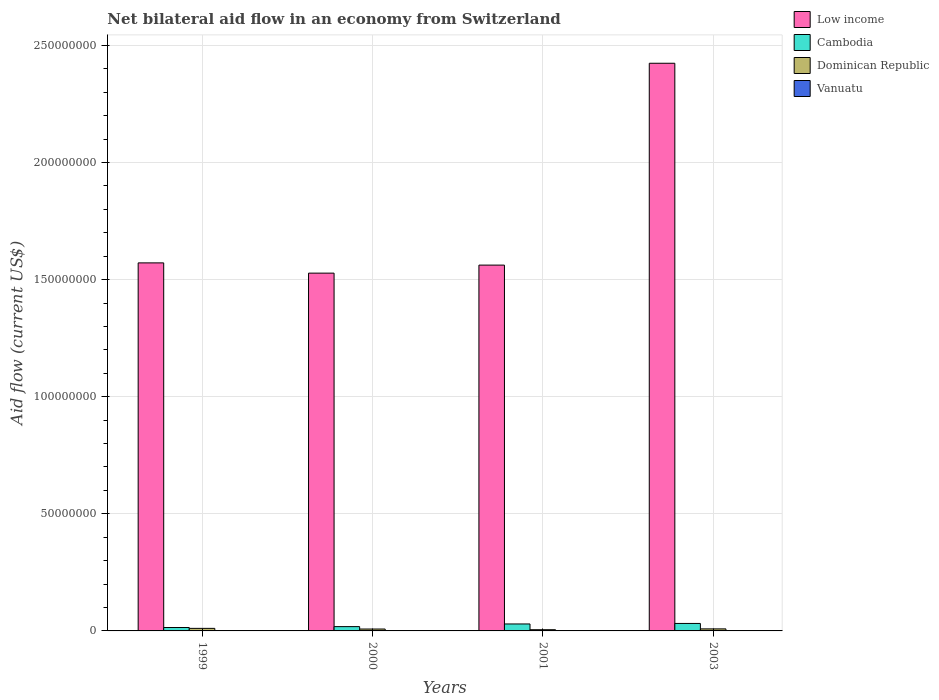How many groups of bars are there?
Offer a terse response. 4. Are the number of bars on each tick of the X-axis equal?
Make the answer very short. Yes. How many bars are there on the 4th tick from the left?
Offer a terse response. 4. In how many cases, is the number of bars for a given year not equal to the number of legend labels?
Offer a terse response. 0. What is the net bilateral aid flow in Low income in 2003?
Make the answer very short. 2.42e+08. Across all years, what is the maximum net bilateral aid flow in Dominican Republic?
Give a very brief answer. 1.09e+06. Across all years, what is the minimum net bilateral aid flow in Dominican Republic?
Provide a short and direct response. 5.20e+05. In which year was the net bilateral aid flow in Dominican Republic maximum?
Your response must be concise. 1999. In which year was the net bilateral aid flow in Dominican Republic minimum?
Provide a succinct answer. 2001. What is the difference between the net bilateral aid flow in Low income in 1999 and that in 2003?
Your answer should be very brief. -8.52e+07. What is the difference between the net bilateral aid flow in Low income in 2000 and the net bilateral aid flow in Cambodia in 2003?
Make the answer very short. 1.50e+08. What is the average net bilateral aid flow in Low income per year?
Provide a short and direct response. 1.77e+08. In the year 2000, what is the difference between the net bilateral aid flow in Low income and net bilateral aid flow in Cambodia?
Provide a succinct answer. 1.51e+08. In how many years, is the net bilateral aid flow in Low income greater than 180000000 US$?
Offer a very short reply. 1. What is the ratio of the net bilateral aid flow in Low income in 2000 to that in 2003?
Give a very brief answer. 0.63. Is the net bilateral aid flow in Low income in 2000 less than that in 2003?
Offer a terse response. Yes. Is the difference between the net bilateral aid flow in Low income in 2001 and 2003 greater than the difference between the net bilateral aid flow in Cambodia in 2001 and 2003?
Provide a succinct answer. No. What is the difference between the highest and the second highest net bilateral aid flow in Cambodia?
Provide a succinct answer. 2.20e+05. What is the difference between the highest and the lowest net bilateral aid flow in Dominican Republic?
Your answer should be very brief. 5.70e+05. In how many years, is the net bilateral aid flow in Cambodia greater than the average net bilateral aid flow in Cambodia taken over all years?
Your response must be concise. 2. What does the 4th bar from the left in 2001 represents?
Offer a terse response. Vanuatu. What does the 3rd bar from the right in 2001 represents?
Keep it short and to the point. Cambodia. Are the values on the major ticks of Y-axis written in scientific E-notation?
Provide a succinct answer. No. How many legend labels are there?
Offer a very short reply. 4. What is the title of the graph?
Your answer should be compact. Net bilateral aid flow in an economy from Switzerland. Does "Ukraine" appear as one of the legend labels in the graph?
Offer a very short reply. No. What is the label or title of the Y-axis?
Provide a short and direct response. Aid flow (current US$). What is the Aid flow (current US$) in Low income in 1999?
Offer a terse response. 1.57e+08. What is the Aid flow (current US$) of Cambodia in 1999?
Make the answer very short. 1.46e+06. What is the Aid flow (current US$) of Dominican Republic in 1999?
Ensure brevity in your answer.  1.09e+06. What is the Aid flow (current US$) of Low income in 2000?
Your response must be concise. 1.53e+08. What is the Aid flow (current US$) of Cambodia in 2000?
Keep it short and to the point. 1.84e+06. What is the Aid flow (current US$) in Dominican Republic in 2000?
Ensure brevity in your answer.  8.10e+05. What is the Aid flow (current US$) in Vanuatu in 2000?
Offer a very short reply. 2.00e+04. What is the Aid flow (current US$) in Low income in 2001?
Give a very brief answer. 1.56e+08. What is the Aid flow (current US$) of Cambodia in 2001?
Provide a succinct answer. 2.97e+06. What is the Aid flow (current US$) of Dominican Republic in 2001?
Your response must be concise. 5.20e+05. What is the Aid flow (current US$) of Low income in 2003?
Ensure brevity in your answer.  2.42e+08. What is the Aid flow (current US$) in Cambodia in 2003?
Ensure brevity in your answer.  3.19e+06. What is the Aid flow (current US$) of Dominican Republic in 2003?
Your response must be concise. 8.70e+05. What is the Aid flow (current US$) of Vanuatu in 2003?
Your answer should be compact. 10000. Across all years, what is the maximum Aid flow (current US$) in Low income?
Provide a succinct answer. 2.42e+08. Across all years, what is the maximum Aid flow (current US$) in Cambodia?
Give a very brief answer. 3.19e+06. Across all years, what is the maximum Aid flow (current US$) in Dominican Republic?
Offer a terse response. 1.09e+06. Across all years, what is the maximum Aid flow (current US$) in Vanuatu?
Offer a terse response. 2.00e+04. Across all years, what is the minimum Aid flow (current US$) in Low income?
Offer a very short reply. 1.53e+08. Across all years, what is the minimum Aid flow (current US$) of Cambodia?
Provide a short and direct response. 1.46e+06. Across all years, what is the minimum Aid flow (current US$) in Dominican Republic?
Offer a very short reply. 5.20e+05. Across all years, what is the minimum Aid flow (current US$) in Vanuatu?
Your response must be concise. 10000. What is the total Aid flow (current US$) of Low income in the graph?
Make the answer very short. 7.09e+08. What is the total Aid flow (current US$) of Cambodia in the graph?
Your answer should be very brief. 9.46e+06. What is the total Aid flow (current US$) in Dominican Republic in the graph?
Keep it short and to the point. 3.29e+06. What is the total Aid flow (current US$) in Vanuatu in the graph?
Offer a very short reply. 7.00e+04. What is the difference between the Aid flow (current US$) of Low income in 1999 and that in 2000?
Keep it short and to the point. 4.38e+06. What is the difference between the Aid flow (current US$) in Cambodia in 1999 and that in 2000?
Keep it short and to the point. -3.80e+05. What is the difference between the Aid flow (current US$) of Low income in 1999 and that in 2001?
Make the answer very short. 9.50e+05. What is the difference between the Aid flow (current US$) of Cambodia in 1999 and that in 2001?
Offer a very short reply. -1.51e+06. What is the difference between the Aid flow (current US$) in Dominican Republic in 1999 and that in 2001?
Make the answer very short. 5.70e+05. What is the difference between the Aid flow (current US$) in Low income in 1999 and that in 2003?
Give a very brief answer. -8.52e+07. What is the difference between the Aid flow (current US$) in Cambodia in 1999 and that in 2003?
Give a very brief answer. -1.73e+06. What is the difference between the Aid flow (current US$) in Dominican Republic in 1999 and that in 2003?
Your response must be concise. 2.20e+05. What is the difference between the Aid flow (current US$) of Low income in 2000 and that in 2001?
Give a very brief answer. -3.43e+06. What is the difference between the Aid flow (current US$) in Cambodia in 2000 and that in 2001?
Your answer should be compact. -1.13e+06. What is the difference between the Aid flow (current US$) in Dominican Republic in 2000 and that in 2001?
Make the answer very short. 2.90e+05. What is the difference between the Aid flow (current US$) in Vanuatu in 2000 and that in 2001?
Make the answer very short. 0. What is the difference between the Aid flow (current US$) in Low income in 2000 and that in 2003?
Your answer should be compact. -8.96e+07. What is the difference between the Aid flow (current US$) in Cambodia in 2000 and that in 2003?
Give a very brief answer. -1.35e+06. What is the difference between the Aid flow (current US$) of Dominican Republic in 2000 and that in 2003?
Your answer should be compact. -6.00e+04. What is the difference between the Aid flow (current US$) of Low income in 2001 and that in 2003?
Your response must be concise. -8.62e+07. What is the difference between the Aid flow (current US$) of Cambodia in 2001 and that in 2003?
Provide a short and direct response. -2.20e+05. What is the difference between the Aid flow (current US$) in Dominican Republic in 2001 and that in 2003?
Your response must be concise. -3.50e+05. What is the difference between the Aid flow (current US$) of Low income in 1999 and the Aid flow (current US$) of Cambodia in 2000?
Provide a succinct answer. 1.55e+08. What is the difference between the Aid flow (current US$) of Low income in 1999 and the Aid flow (current US$) of Dominican Republic in 2000?
Make the answer very short. 1.56e+08. What is the difference between the Aid flow (current US$) in Low income in 1999 and the Aid flow (current US$) in Vanuatu in 2000?
Provide a succinct answer. 1.57e+08. What is the difference between the Aid flow (current US$) in Cambodia in 1999 and the Aid flow (current US$) in Dominican Republic in 2000?
Your answer should be compact. 6.50e+05. What is the difference between the Aid flow (current US$) of Cambodia in 1999 and the Aid flow (current US$) of Vanuatu in 2000?
Give a very brief answer. 1.44e+06. What is the difference between the Aid flow (current US$) of Dominican Republic in 1999 and the Aid flow (current US$) of Vanuatu in 2000?
Keep it short and to the point. 1.07e+06. What is the difference between the Aid flow (current US$) in Low income in 1999 and the Aid flow (current US$) in Cambodia in 2001?
Make the answer very short. 1.54e+08. What is the difference between the Aid flow (current US$) of Low income in 1999 and the Aid flow (current US$) of Dominican Republic in 2001?
Keep it short and to the point. 1.57e+08. What is the difference between the Aid flow (current US$) in Low income in 1999 and the Aid flow (current US$) in Vanuatu in 2001?
Provide a short and direct response. 1.57e+08. What is the difference between the Aid flow (current US$) in Cambodia in 1999 and the Aid flow (current US$) in Dominican Republic in 2001?
Ensure brevity in your answer.  9.40e+05. What is the difference between the Aid flow (current US$) in Cambodia in 1999 and the Aid flow (current US$) in Vanuatu in 2001?
Offer a terse response. 1.44e+06. What is the difference between the Aid flow (current US$) of Dominican Republic in 1999 and the Aid flow (current US$) of Vanuatu in 2001?
Provide a succinct answer. 1.07e+06. What is the difference between the Aid flow (current US$) in Low income in 1999 and the Aid flow (current US$) in Cambodia in 2003?
Offer a terse response. 1.54e+08. What is the difference between the Aid flow (current US$) of Low income in 1999 and the Aid flow (current US$) of Dominican Republic in 2003?
Offer a very short reply. 1.56e+08. What is the difference between the Aid flow (current US$) of Low income in 1999 and the Aid flow (current US$) of Vanuatu in 2003?
Keep it short and to the point. 1.57e+08. What is the difference between the Aid flow (current US$) in Cambodia in 1999 and the Aid flow (current US$) in Dominican Republic in 2003?
Provide a succinct answer. 5.90e+05. What is the difference between the Aid flow (current US$) of Cambodia in 1999 and the Aid flow (current US$) of Vanuatu in 2003?
Your answer should be compact. 1.45e+06. What is the difference between the Aid flow (current US$) in Dominican Republic in 1999 and the Aid flow (current US$) in Vanuatu in 2003?
Give a very brief answer. 1.08e+06. What is the difference between the Aid flow (current US$) of Low income in 2000 and the Aid flow (current US$) of Cambodia in 2001?
Make the answer very short. 1.50e+08. What is the difference between the Aid flow (current US$) of Low income in 2000 and the Aid flow (current US$) of Dominican Republic in 2001?
Make the answer very short. 1.52e+08. What is the difference between the Aid flow (current US$) of Low income in 2000 and the Aid flow (current US$) of Vanuatu in 2001?
Offer a terse response. 1.53e+08. What is the difference between the Aid flow (current US$) of Cambodia in 2000 and the Aid flow (current US$) of Dominican Republic in 2001?
Provide a succinct answer. 1.32e+06. What is the difference between the Aid flow (current US$) in Cambodia in 2000 and the Aid flow (current US$) in Vanuatu in 2001?
Keep it short and to the point. 1.82e+06. What is the difference between the Aid flow (current US$) in Dominican Republic in 2000 and the Aid flow (current US$) in Vanuatu in 2001?
Keep it short and to the point. 7.90e+05. What is the difference between the Aid flow (current US$) of Low income in 2000 and the Aid flow (current US$) of Cambodia in 2003?
Offer a terse response. 1.50e+08. What is the difference between the Aid flow (current US$) of Low income in 2000 and the Aid flow (current US$) of Dominican Republic in 2003?
Ensure brevity in your answer.  1.52e+08. What is the difference between the Aid flow (current US$) of Low income in 2000 and the Aid flow (current US$) of Vanuatu in 2003?
Provide a succinct answer. 1.53e+08. What is the difference between the Aid flow (current US$) of Cambodia in 2000 and the Aid flow (current US$) of Dominican Republic in 2003?
Offer a terse response. 9.70e+05. What is the difference between the Aid flow (current US$) in Cambodia in 2000 and the Aid flow (current US$) in Vanuatu in 2003?
Give a very brief answer. 1.83e+06. What is the difference between the Aid flow (current US$) in Dominican Republic in 2000 and the Aid flow (current US$) in Vanuatu in 2003?
Make the answer very short. 8.00e+05. What is the difference between the Aid flow (current US$) of Low income in 2001 and the Aid flow (current US$) of Cambodia in 2003?
Give a very brief answer. 1.53e+08. What is the difference between the Aid flow (current US$) in Low income in 2001 and the Aid flow (current US$) in Dominican Republic in 2003?
Offer a very short reply. 1.55e+08. What is the difference between the Aid flow (current US$) in Low income in 2001 and the Aid flow (current US$) in Vanuatu in 2003?
Your answer should be compact. 1.56e+08. What is the difference between the Aid flow (current US$) of Cambodia in 2001 and the Aid flow (current US$) of Dominican Republic in 2003?
Your response must be concise. 2.10e+06. What is the difference between the Aid flow (current US$) in Cambodia in 2001 and the Aid flow (current US$) in Vanuatu in 2003?
Make the answer very short. 2.96e+06. What is the difference between the Aid flow (current US$) in Dominican Republic in 2001 and the Aid flow (current US$) in Vanuatu in 2003?
Provide a succinct answer. 5.10e+05. What is the average Aid flow (current US$) of Low income per year?
Make the answer very short. 1.77e+08. What is the average Aid flow (current US$) of Cambodia per year?
Ensure brevity in your answer.  2.36e+06. What is the average Aid flow (current US$) of Dominican Republic per year?
Ensure brevity in your answer.  8.22e+05. What is the average Aid flow (current US$) of Vanuatu per year?
Provide a short and direct response. 1.75e+04. In the year 1999, what is the difference between the Aid flow (current US$) in Low income and Aid flow (current US$) in Cambodia?
Your answer should be very brief. 1.56e+08. In the year 1999, what is the difference between the Aid flow (current US$) of Low income and Aid flow (current US$) of Dominican Republic?
Provide a succinct answer. 1.56e+08. In the year 1999, what is the difference between the Aid flow (current US$) of Low income and Aid flow (current US$) of Vanuatu?
Ensure brevity in your answer.  1.57e+08. In the year 1999, what is the difference between the Aid flow (current US$) in Cambodia and Aid flow (current US$) in Dominican Republic?
Give a very brief answer. 3.70e+05. In the year 1999, what is the difference between the Aid flow (current US$) of Cambodia and Aid flow (current US$) of Vanuatu?
Your answer should be very brief. 1.44e+06. In the year 1999, what is the difference between the Aid flow (current US$) of Dominican Republic and Aid flow (current US$) of Vanuatu?
Your answer should be very brief. 1.07e+06. In the year 2000, what is the difference between the Aid flow (current US$) in Low income and Aid flow (current US$) in Cambodia?
Your response must be concise. 1.51e+08. In the year 2000, what is the difference between the Aid flow (current US$) in Low income and Aid flow (current US$) in Dominican Republic?
Your answer should be very brief. 1.52e+08. In the year 2000, what is the difference between the Aid flow (current US$) of Low income and Aid flow (current US$) of Vanuatu?
Keep it short and to the point. 1.53e+08. In the year 2000, what is the difference between the Aid flow (current US$) in Cambodia and Aid flow (current US$) in Dominican Republic?
Offer a very short reply. 1.03e+06. In the year 2000, what is the difference between the Aid flow (current US$) of Cambodia and Aid flow (current US$) of Vanuatu?
Make the answer very short. 1.82e+06. In the year 2000, what is the difference between the Aid flow (current US$) of Dominican Republic and Aid flow (current US$) of Vanuatu?
Provide a succinct answer. 7.90e+05. In the year 2001, what is the difference between the Aid flow (current US$) of Low income and Aid flow (current US$) of Cambodia?
Give a very brief answer. 1.53e+08. In the year 2001, what is the difference between the Aid flow (current US$) in Low income and Aid flow (current US$) in Dominican Republic?
Your response must be concise. 1.56e+08. In the year 2001, what is the difference between the Aid flow (current US$) in Low income and Aid flow (current US$) in Vanuatu?
Your answer should be compact. 1.56e+08. In the year 2001, what is the difference between the Aid flow (current US$) in Cambodia and Aid flow (current US$) in Dominican Republic?
Your response must be concise. 2.45e+06. In the year 2001, what is the difference between the Aid flow (current US$) in Cambodia and Aid flow (current US$) in Vanuatu?
Provide a short and direct response. 2.95e+06. In the year 2003, what is the difference between the Aid flow (current US$) of Low income and Aid flow (current US$) of Cambodia?
Your response must be concise. 2.39e+08. In the year 2003, what is the difference between the Aid flow (current US$) of Low income and Aid flow (current US$) of Dominican Republic?
Make the answer very short. 2.42e+08. In the year 2003, what is the difference between the Aid flow (current US$) of Low income and Aid flow (current US$) of Vanuatu?
Offer a very short reply. 2.42e+08. In the year 2003, what is the difference between the Aid flow (current US$) in Cambodia and Aid flow (current US$) in Dominican Republic?
Provide a short and direct response. 2.32e+06. In the year 2003, what is the difference between the Aid flow (current US$) in Cambodia and Aid flow (current US$) in Vanuatu?
Make the answer very short. 3.18e+06. In the year 2003, what is the difference between the Aid flow (current US$) of Dominican Republic and Aid flow (current US$) of Vanuatu?
Provide a short and direct response. 8.60e+05. What is the ratio of the Aid flow (current US$) of Low income in 1999 to that in 2000?
Offer a terse response. 1.03. What is the ratio of the Aid flow (current US$) of Cambodia in 1999 to that in 2000?
Your response must be concise. 0.79. What is the ratio of the Aid flow (current US$) in Dominican Republic in 1999 to that in 2000?
Keep it short and to the point. 1.35. What is the ratio of the Aid flow (current US$) of Vanuatu in 1999 to that in 2000?
Your answer should be compact. 1. What is the ratio of the Aid flow (current US$) of Cambodia in 1999 to that in 2001?
Make the answer very short. 0.49. What is the ratio of the Aid flow (current US$) of Dominican Republic in 1999 to that in 2001?
Offer a very short reply. 2.1. What is the ratio of the Aid flow (current US$) of Low income in 1999 to that in 2003?
Your response must be concise. 0.65. What is the ratio of the Aid flow (current US$) of Cambodia in 1999 to that in 2003?
Make the answer very short. 0.46. What is the ratio of the Aid flow (current US$) in Dominican Republic in 1999 to that in 2003?
Make the answer very short. 1.25. What is the ratio of the Aid flow (current US$) of Cambodia in 2000 to that in 2001?
Offer a very short reply. 0.62. What is the ratio of the Aid flow (current US$) of Dominican Republic in 2000 to that in 2001?
Provide a short and direct response. 1.56. What is the ratio of the Aid flow (current US$) of Low income in 2000 to that in 2003?
Keep it short and to the point. 0.63. What is the ratio of the Aid flow (current US$) of Cambodia in 2000 to that in 2003?
Your answer should be compact. 0.58. What is the ratio of the Aid flow (current US$) in Low income in 2001 to that in 2003?
Give a very brief answer. 0.64. What is the ratio of the Aid flow (current US$) of Dominican Republic in 2001 to that in 2003?
Ensure brevity in your answer.  0.6. What is the ratio of the Aid flow (current US$) in Vanuatu in 2001 to that in 2003?
Ensure brevity in your answer.  2. What is the difference between the highest and the second highest Aid flow (current US$) of Low income?
Keep it short and to the point. 8.52e+07. What is the difference between the highest and the second highest Aid flow (current US$) in Cambodia?
Your answer should be compact. 2.20e+05. What is the difference between the highest and the second highest Aid flow (current US$) of Dominican Republic?
Offer a very short reply. 2.20e+05. What is the difference between the highest and the lowest Aid flow (current US$) of Low income?
Offer a terse response. 8.96e+07. What is the difference between the highest and the lowest Aid flow (current US$) in Cambodia?
Make the answer very short. 1.73e+06. What is the difference between the highest and the lowest Aid flow (current US$) of Dominican Republic?
Keep it short and to the point. 5.70e+05. What is the difference between the highest and the lowest Aid flow (current US$) in Vanuatu?
Keep it short and to the point. 10000. 